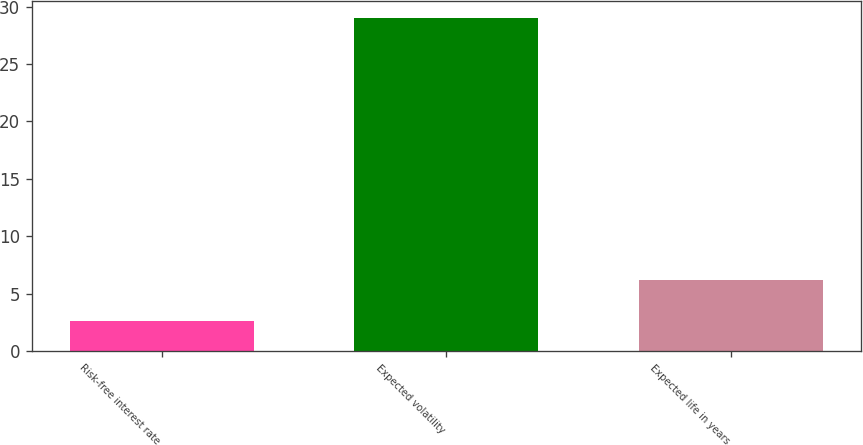<chart> <loc_0><loc_0><loc_500><loc_500><bar_chart><fcel>Risk-free interest rate<fcel>Expected volatility<fcel>Expected life in years<nl><fcel>2.62<fcel>29<fcel>6.15<nl></chart> 